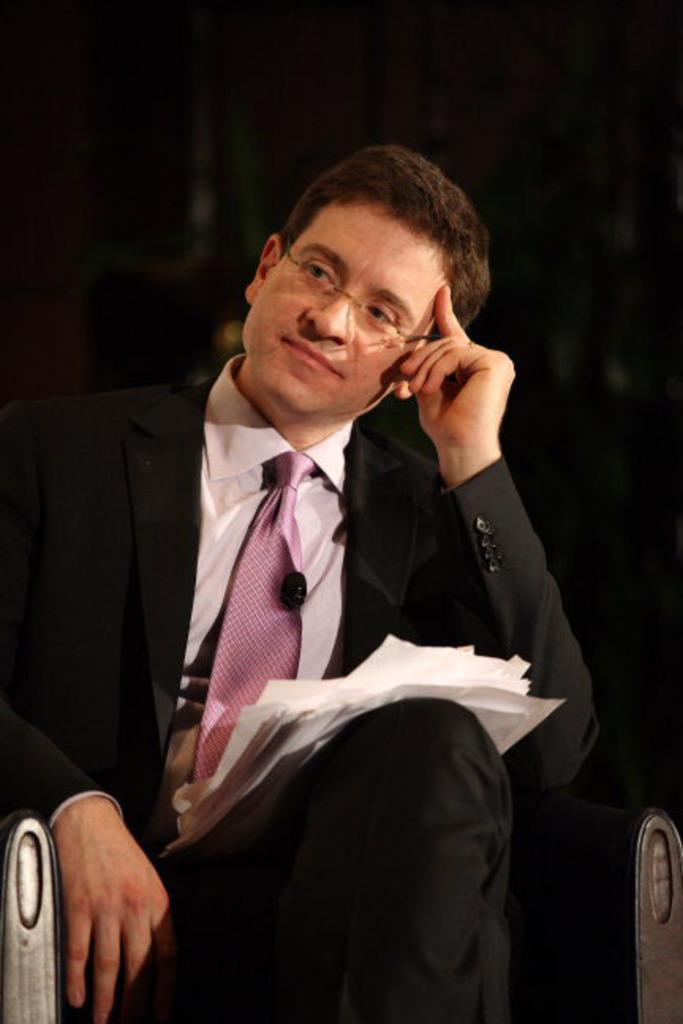Can you describe this image briefly? In the picture we can see a man sitting on the chair, he is wearing a black color blazer, pink tie and white shirt and keeping a hand on his forehead and on his lap we can see some papers. 